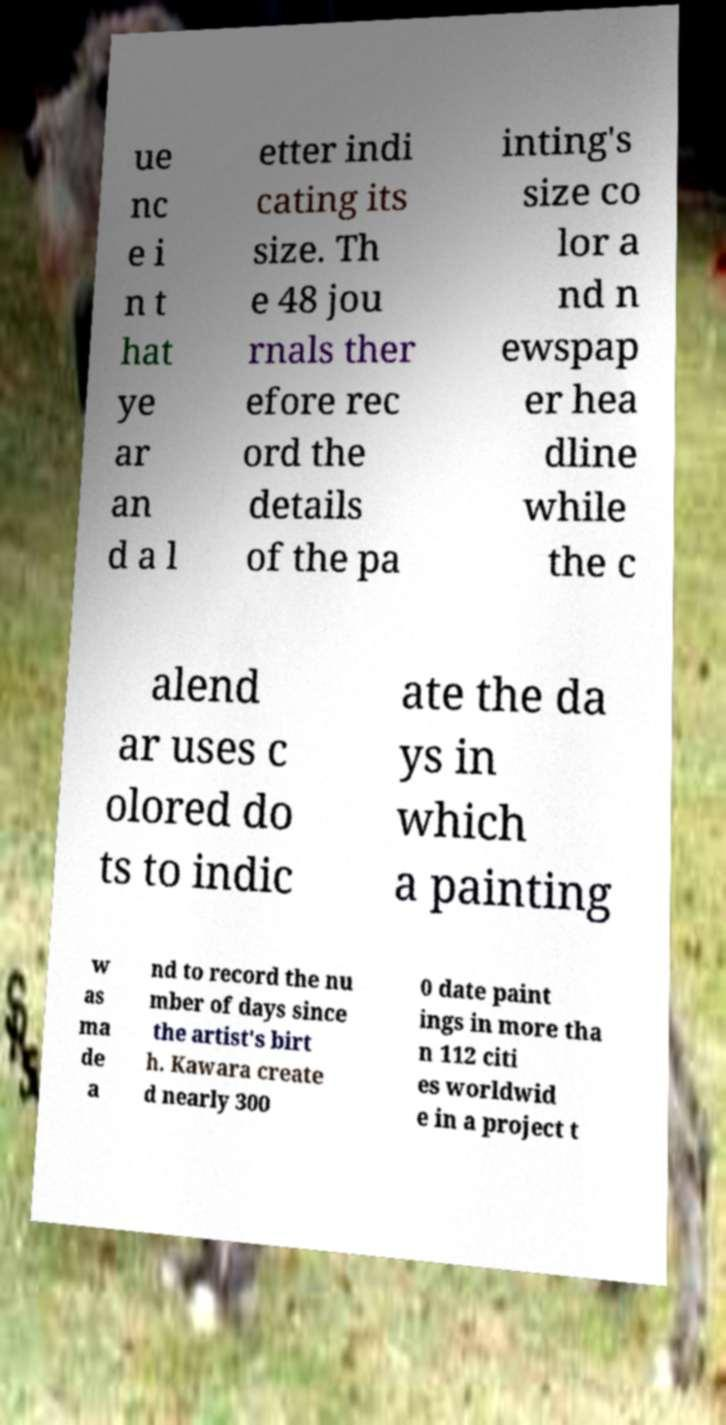Could you assist in decoding the text presented in this image and type it out clearly? ue nc e i n t hat ye ar an d a l etter indi cating its size. Th e 48 jou rnals ther efore rec ord the details of the pa inting's size co lor a nd n ewspap er hea dline while the c alend ar uses c olored do ts to indic ate the da ys in which a painting w as ma de a nd to record the nu mber of days since the artist's birt h. Kawara create d nearly 300 0 date paint ings in more tha n 112 citi es worldwid e in a project t 